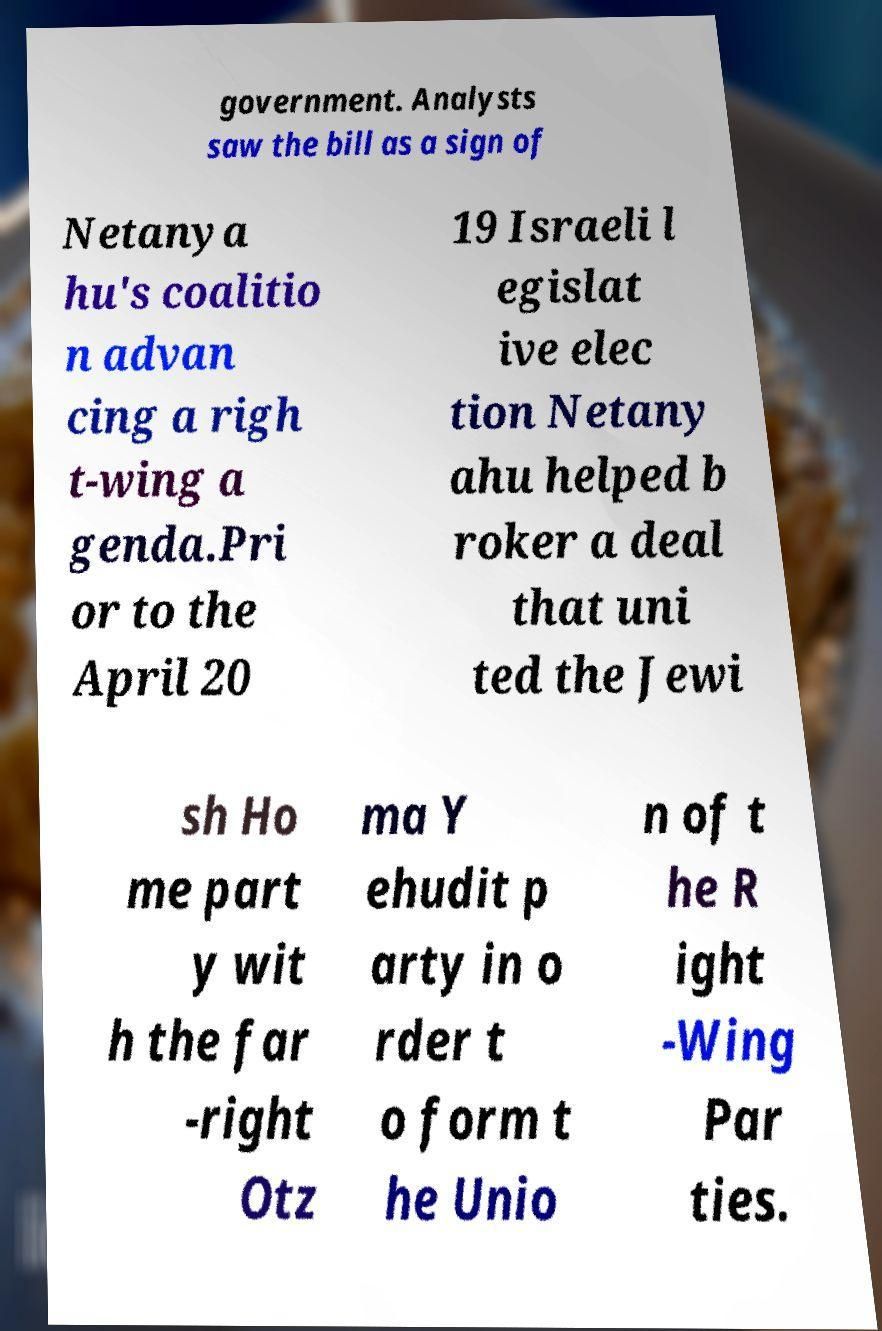Please identify and transcribe the text found in this image. government. Analysts saw the bill as a sign of Netanya hu's coalitio n advan cing a righ t-wing a genda.Pri or to the April 20 19 Israeli l egislat ive elec tion Netany ahu helped b roker a deal that uni ted the Jewi sh Ho me part y wit h the far -right Otz ma Y ehudit p arty in o rder t o form t he Unio n of t he R ight -Wing Par ties. 